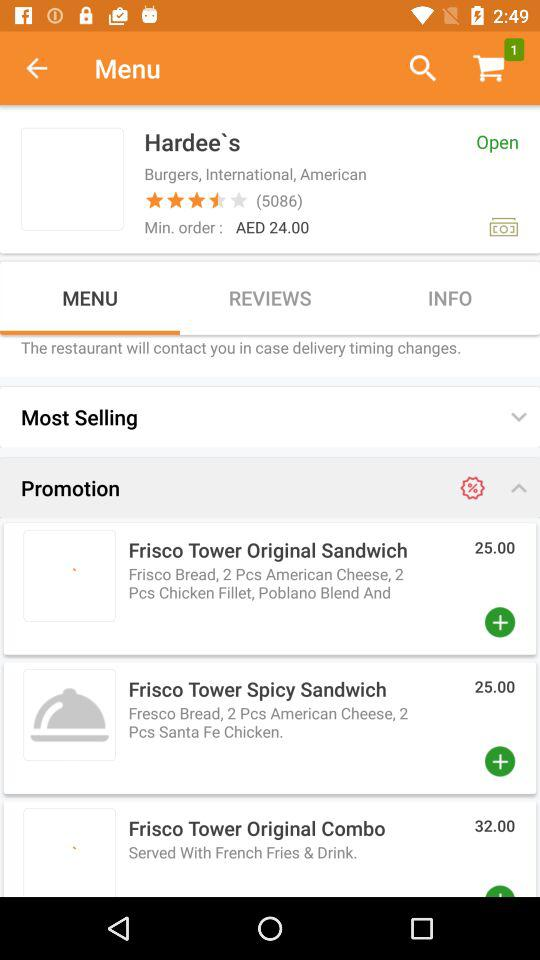How much is the price of the "Frisco Tower Original Combo"? The price of the "Frisco Tower Original Combo" is AED 32. 